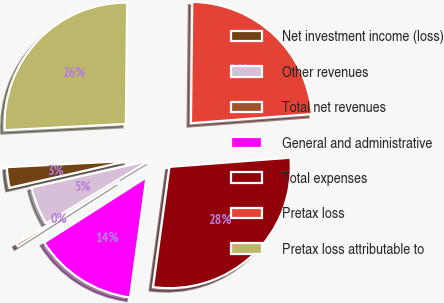Convert chart to OTSL. <chart><loc_0><loc_0><loc_500><loc_500><pie_chart><fcel>Net investment income (loss)<fcel>Other revenues<fcel>Total net revenues<fcel>General and administrative<fcel>Total expenses<fcel>Pretax loss<fcel>Pretax loss attributable to<nl><fcel>2.74%<fcel>5.1%<fcel>0.38%<fcel>13.8%<fcel>28.36%<fcel>23.63%<fcel>25.99%<nl></chart> 